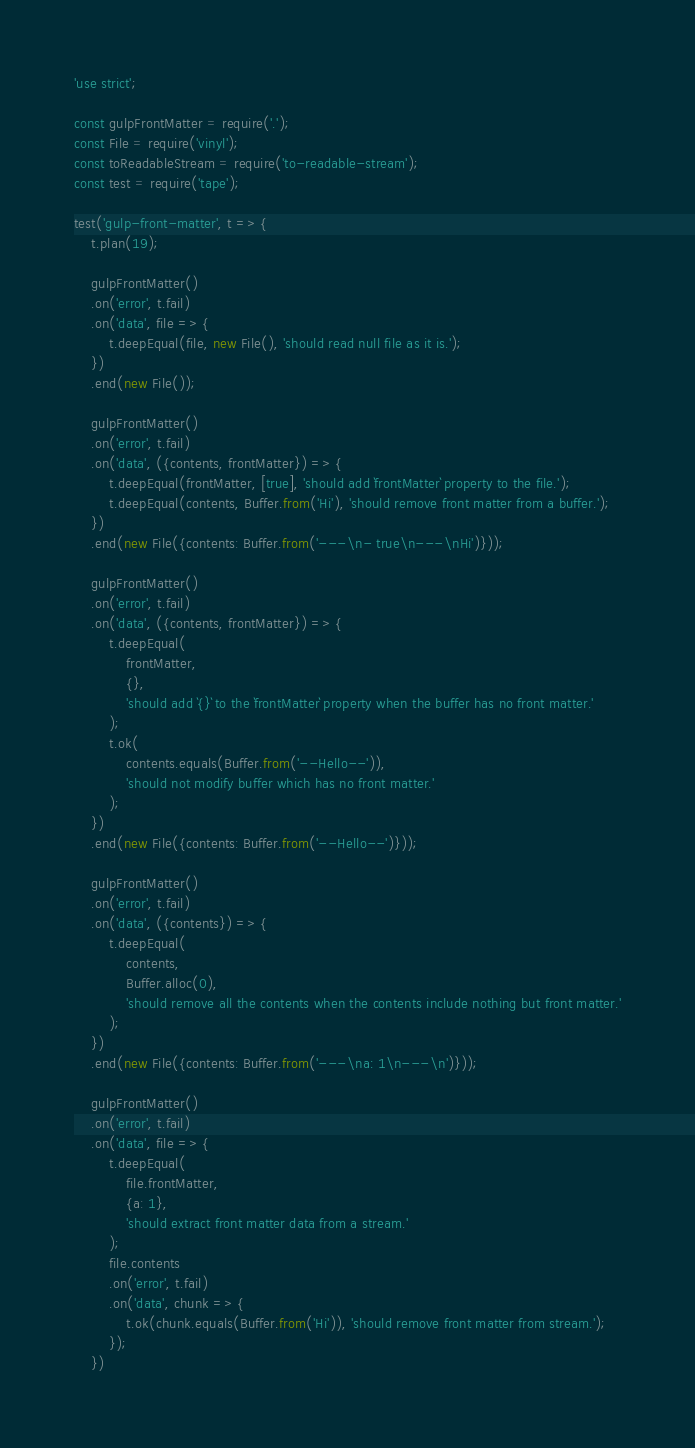Convert code to text. <code><loc_0><loc_0><loc_500><loc_500><_JavaScript_>'use strict';

const gulpFrontMatter = require('.');
const File = require('vinyl');
const toReadableStream = require('to-readable-stream');
const test = require('tape');

test('gulp-front-matter', t => {
	t.plan(19);

	gulpFrontMatter()
	.on('error', t.fail)
	.on('data', file => {
		t.deepEqual(file, new File(), 'should read null file as it is.');
	})
	.end(new File());

	gulpFrontMatter()
	.on('error', t.fail)
	.on('data', ({contents, frontMatter}) => {
		t.deepEqual(frontMatter, [true], 'should add `frontMatter` property to the file.');
		t.deepEqual(contents, Buffer.from('Hi'), 'should remove front matter from a buffer.');
	})
	.end(new File({contents: Buffer.from('---\n- true\n---\nHi')}));

	gulpFrontMatter()
	.on('error', t.fail)
	.on('data', ({contents, frontMatter}) => {
		t.deepEqual(
			frontMatter,
			{},
			'should add `{}` to the `frontMatter` property when the buffer has no front matter.'
		);
		t.ok(
			contents.equals(Buffer.from('--Hello--')),
			'should not modify buffer which has no front matter.'
		);
	})
	.end(new File({contents: Buffer.from('--Hello--')}));

	gulpFrontMatter()
	.on('error', t.fail)
	.on('data', ({contents}) => {
		t.deepEqual(
			contents,
			Buffer.alloc(0),
			'should remove all the contents when the contents include nothing but front matter.'
		);
	})
	.end(new File({contents: Buffer.from('---\na: 1\n---\n')}));

	gulpFrontMatter()
	.on('error', t.fail)
	.on('data', file => {
		t.deepEqual(
			file.frontMatter,
			{a: 1},
			'should extract front matter data from a stream.'
		);
		file.contents
		.on('error', t.fail)
		.on('data', chunk => {
			t.ok(chunk.equals(Buffer.from('Hi')), 'should remove front matter from stream.');
		});
	})</code> 